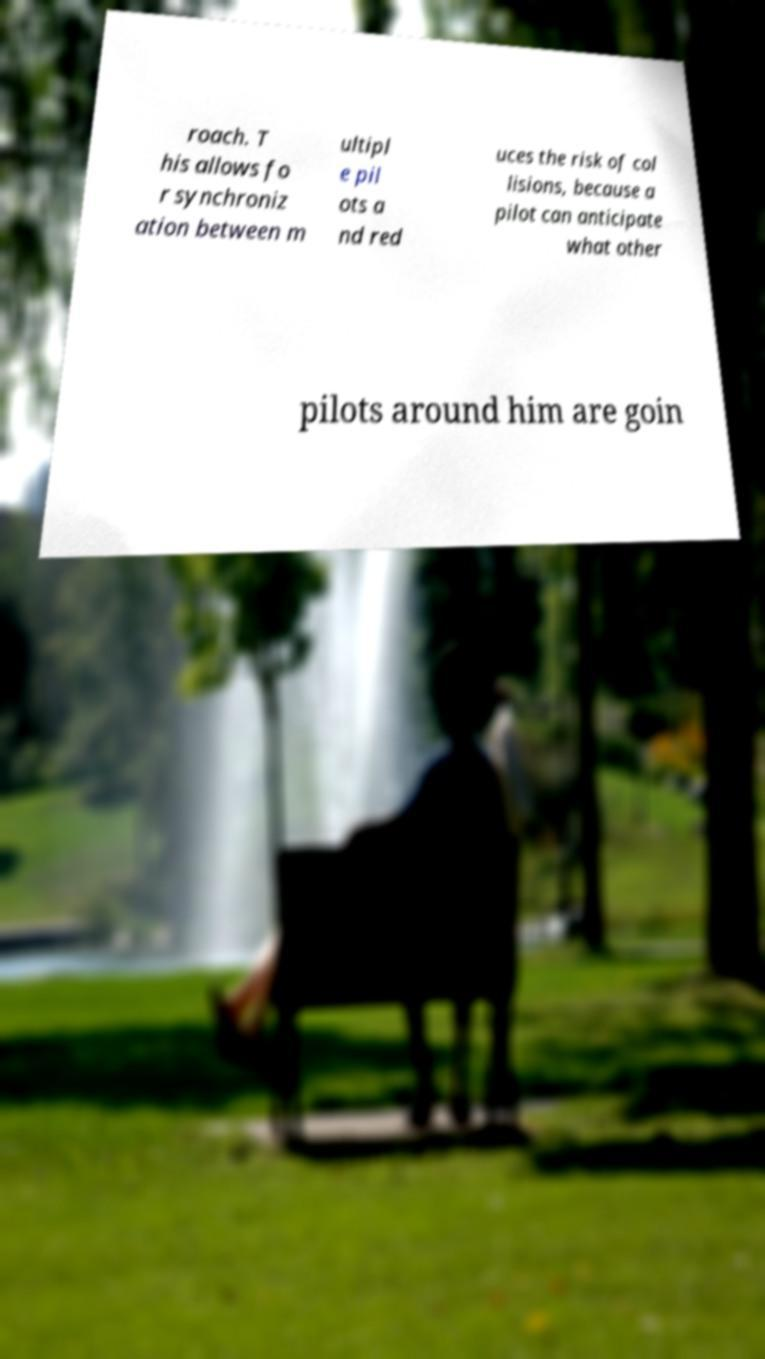I need the written content from this picture converted into text. Can you do that? roach. T his allows fo r synchroniz ation between m ultipl e pil ots a nd red uces the risk of col lisions, because a pilot can anticipate what other pilots around him are goin 